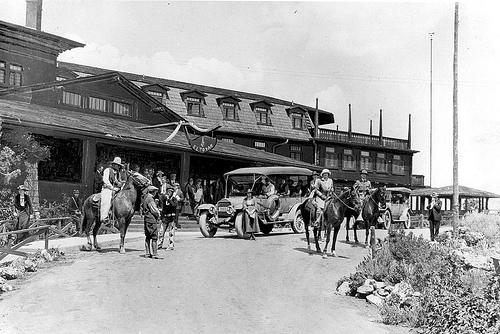Question: where was the photo taken?
Choices:
A. At the swimming pool.
B. In the alley.
C. In the skatepark.
D. On the street.
Answer with the letter. Answer: D Question: what type of photo is shown?
Choices:
A. Black and white.
B. Color.
C. Portrait.
D. Snapshot.
Answer with the letter. Answer: A Question: how many horses are shown?
Choices:
A. Two.
B. Three.
C. One.
D. Four.
Answer with the letter. Answer: B Question: what type of vehicle is shown?
Choices:
A. Bus.
B. Train.
C. Truck.
D. Car.
Answer with the letter. Answer: D Question: what is in the background?
Choices:
A. Zoo.
B. School.
C. House.
D. Building.
Answer with the letter. Answer: D 